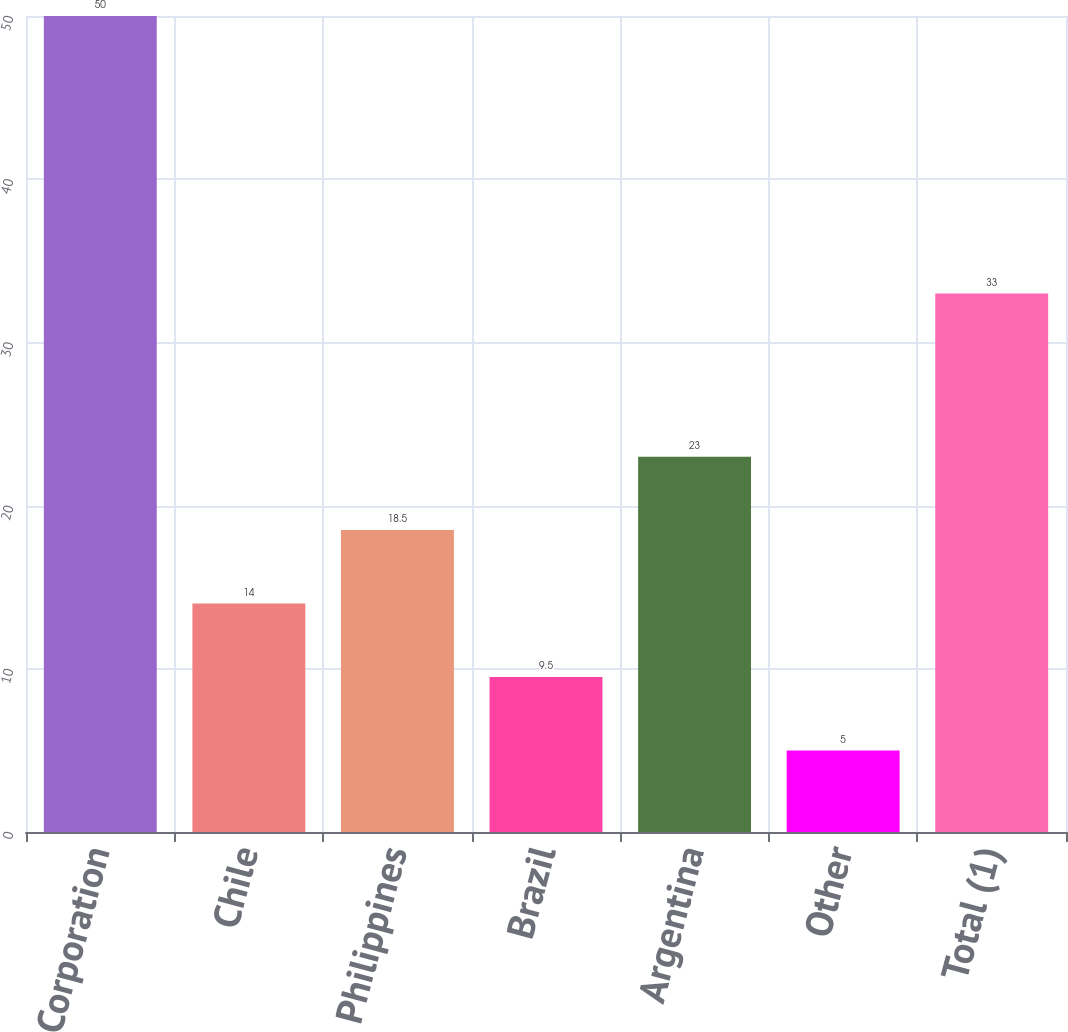<chart> <loc_0><loc_0><loc_500><loc_500><bar_chart><fcel>AES Corporation<fcel>Chile<fcel>Philippines<fcel>Brazil<fcel>Argentina<fcel>Other<fcel>Total (1)<nl><fcel>50<fcel>14<fcel>18.5<fcel>9.5<fcel>23<fcel>5<fcel>33<nl></chart> 